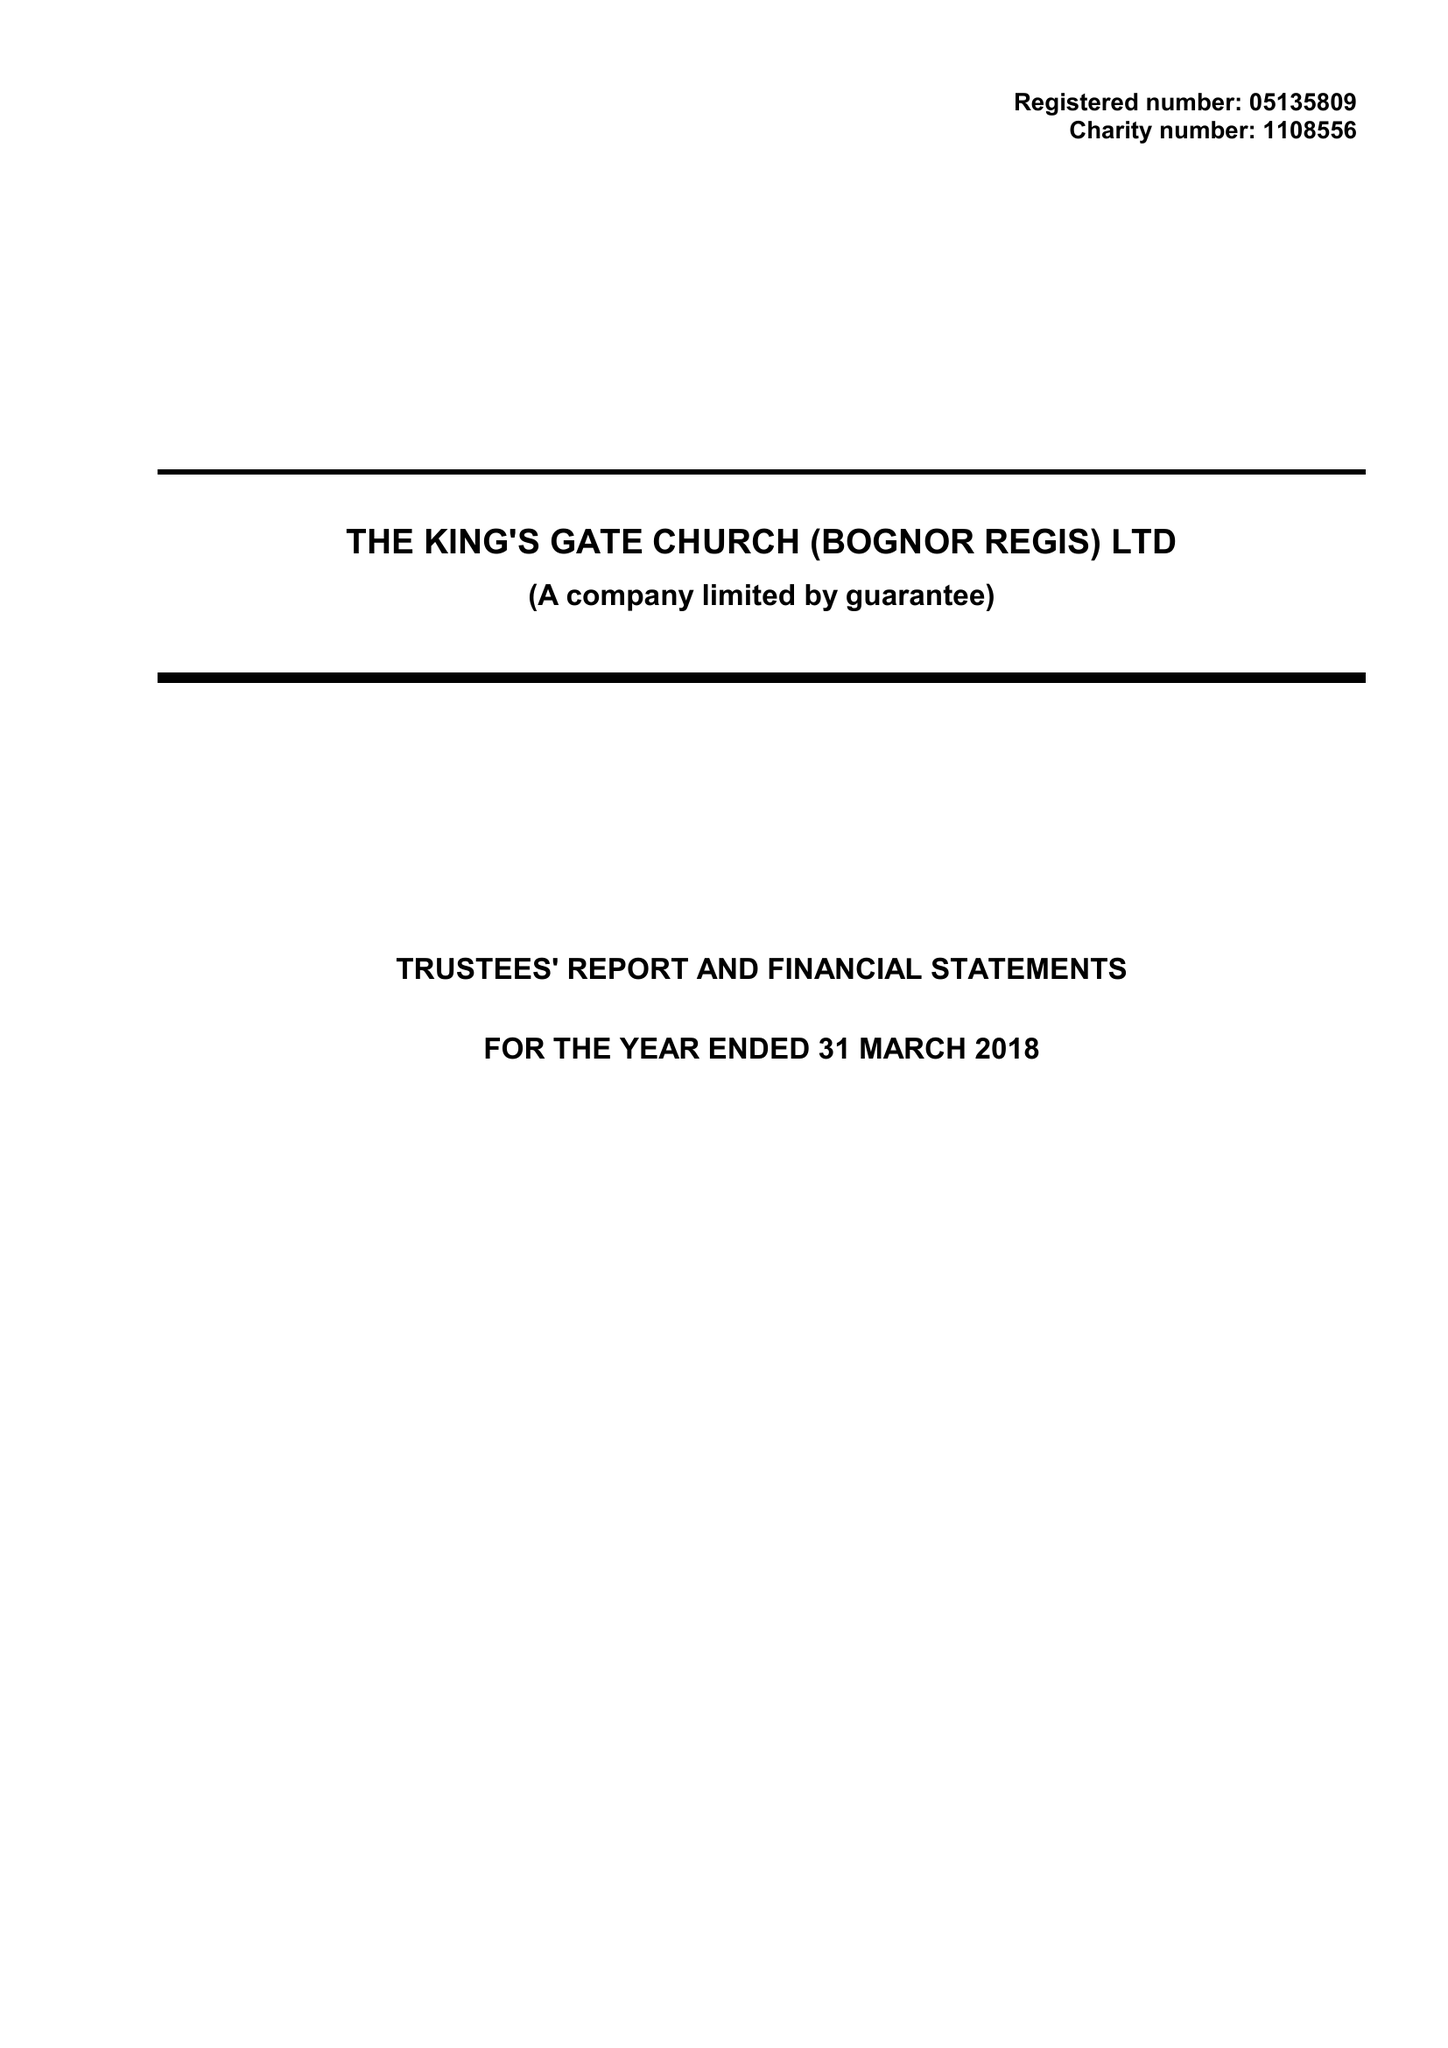What is the value for the address__street_line?
Answer the question using a single word or phrase. 132 LONDON ROAD 